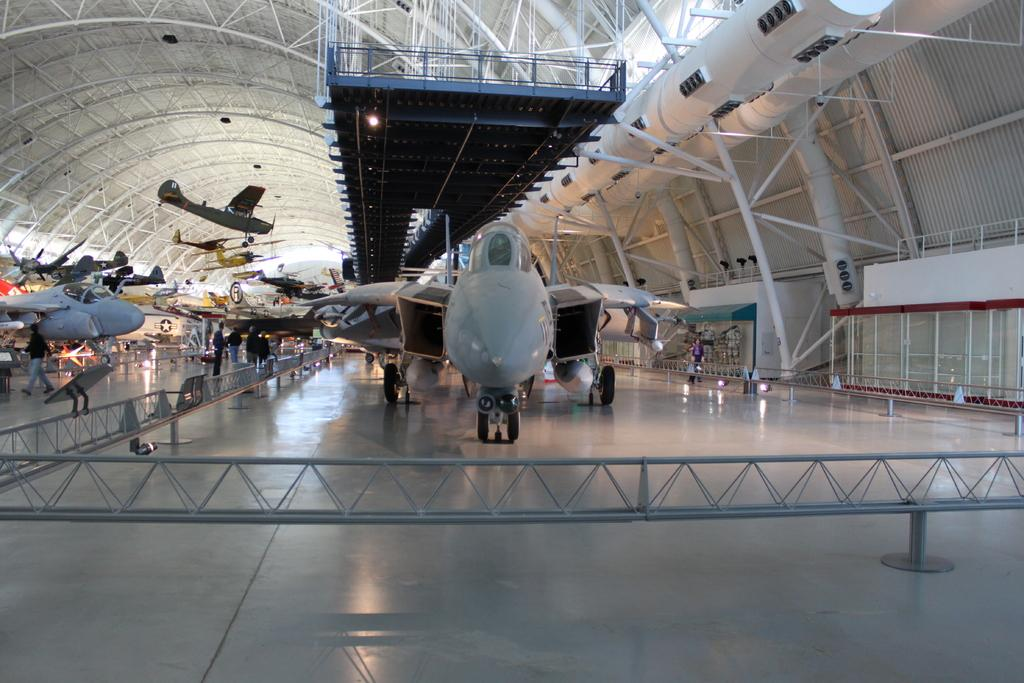What is the main subject of the image? The main subject of the image is an aeroplane. Can you describe the aeroplane in the middle of the image? The aeroplane in the middle of the image is grey in color. Are there any other aeroplanes visible in the image? Yes, there are other aeroplanes on the left side of the image. What type of tomatoes are being used for the haircut in the image? There is no reference to tomatoes or a haircut in the image; it features an aeroplane and other aeroplanes. 